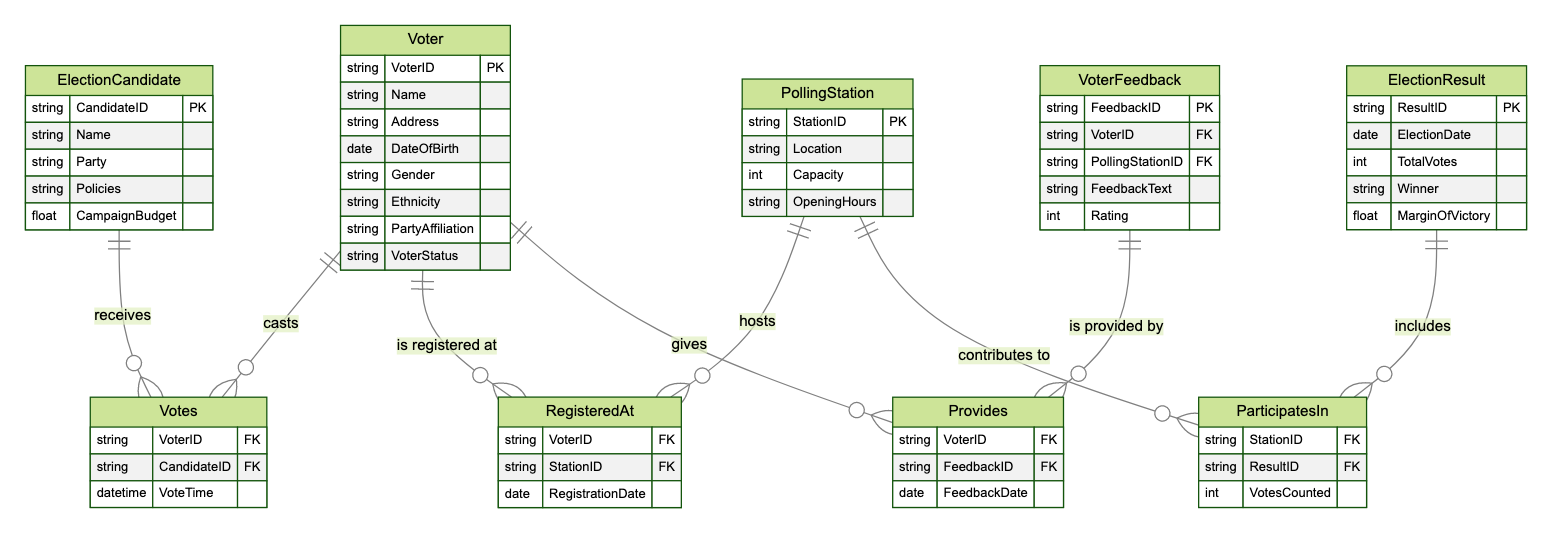What entities are in the diagram? The diagram lists five entities, which are Voter, Polling Station, Election Candidate, Election Result, and Voter Feedback.
Answer: Voter, Polling Station, Election Candidate, Election Result, Voter Feedback How many attributes does the Voter entity have? The Voter entity includes eight attributes: VoterID, Name, Address, DateOfBirth, Gender, Ethnicity, PartyAffiliation, and VoterStatus.
Answer: Eight What relationship exists between the Voter and Election Candidate entities? The relationship between the Voter and Election Candidate entities is named "Votes," indicating that voters cast votes for candidates.
Answer: Votes How many relationships are present in the diagram? The diagram shows a total of four relationships connecting the entities: Votes, RegisteredAt, ParticipatesIn, and Provides.
Answer: Four What attribute is shared between Voter and VoterFeedback? The shared attribute is VoterID, which connects the Voter entity to the VoterFeedback entity, linking feedback to specific voters.
Answer: VoterID Which entity has the attribute "OpeningHours"? The attribute "OpeningHours" belongs to the Polling Station entity, which specifies the hours during which the polling station is open.
Answer: Polling Station What is the primary key of the ElectionResult entity? The primary key of the ElectionResult entity is ResultID, which uniquely identifies each election result in the database.
Answer: ResultID What does the relationship "RegisteredAt" signify? The relationship "RegisteredAt" signifies that a voter is registered at a specific polling station, which creates a link between voters and polling locations.
Answer: RegisteredAt How many total votes are counted in the ElectionResult entity? The total votes counted in the ElectionResult entity is indicated by the TotalVotes attribute, which records the number of votes received in that election.
Answer: TotalVotes 